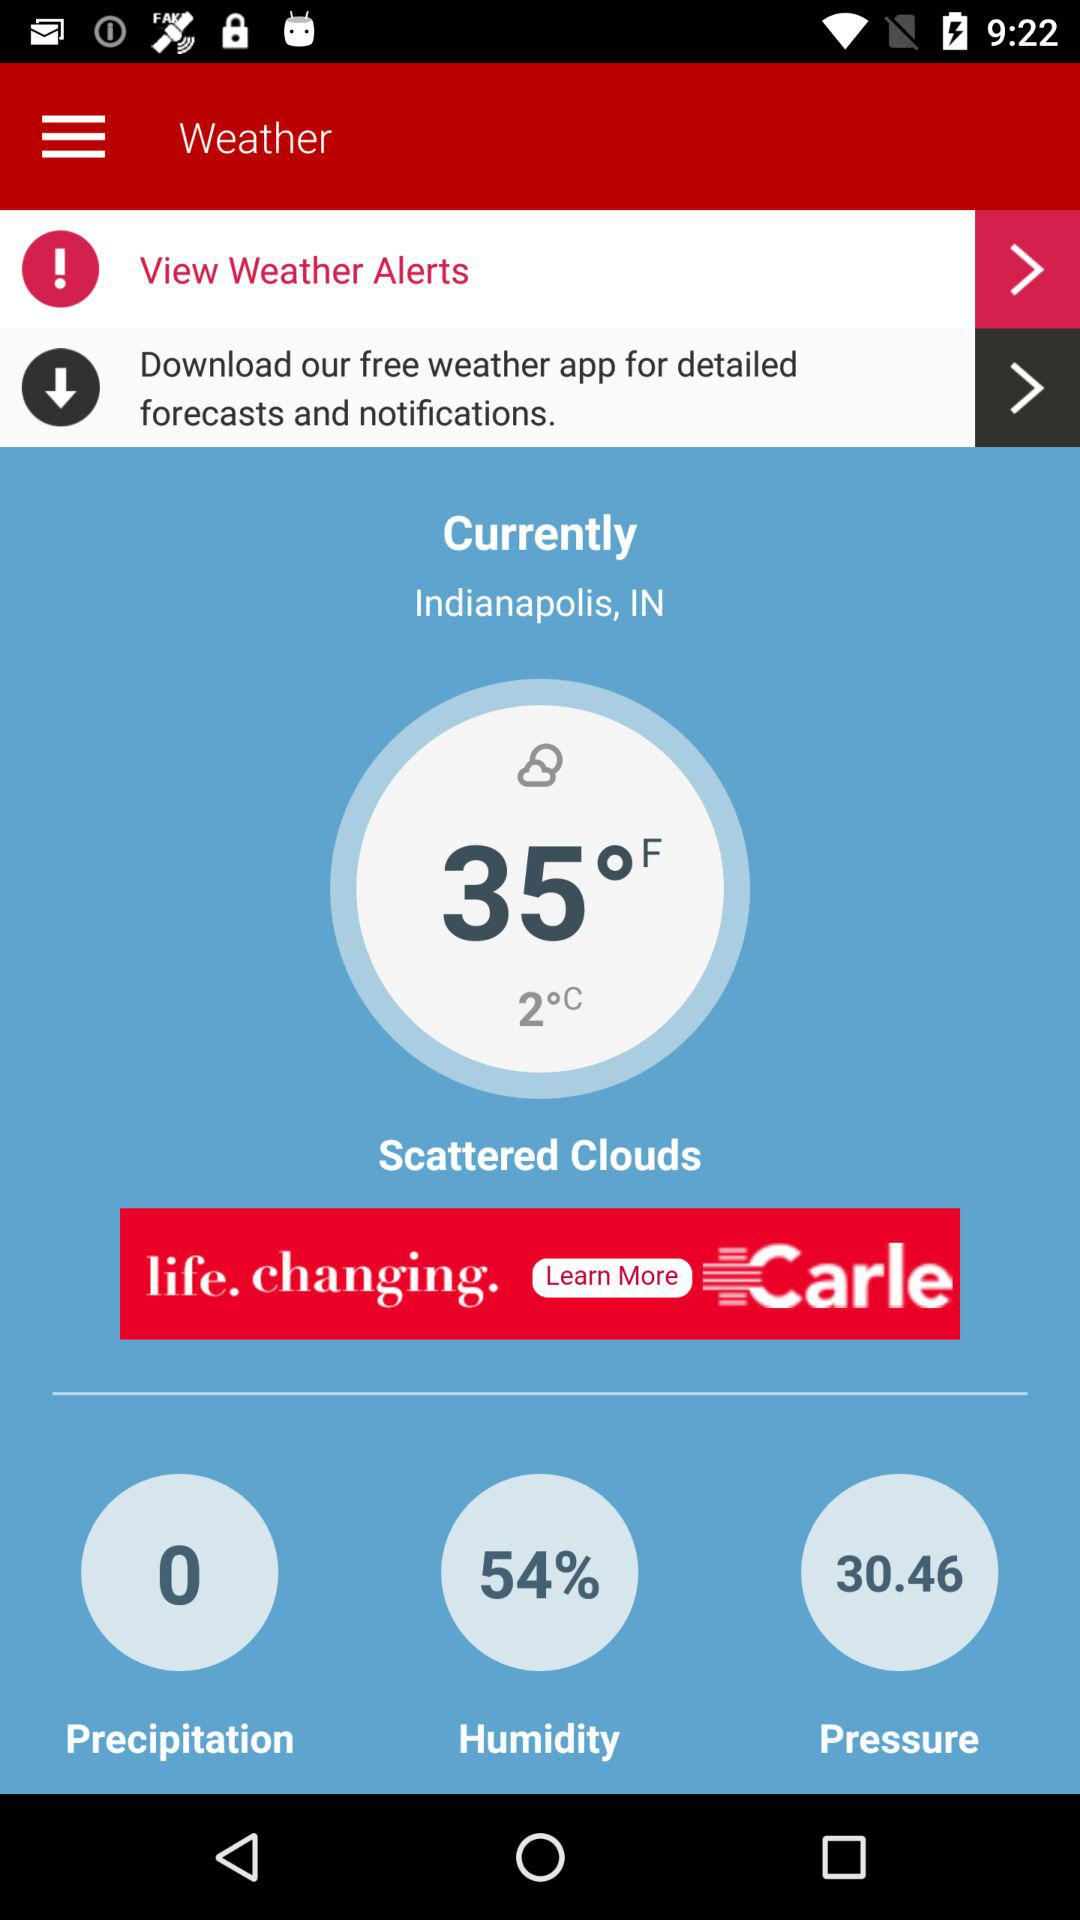What percentage of humidity is given? The percentage of humidity is 54. 